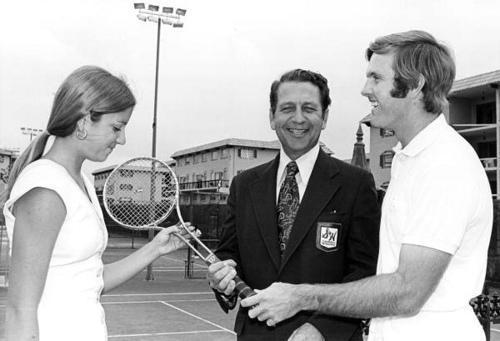How many lights are on each pole?
Give a very brief answer. 8. How many people are there?
Give a very brief answer. 3. How many dolphins are painted on the boats in this photo?
Give a very brief answer. 0. 